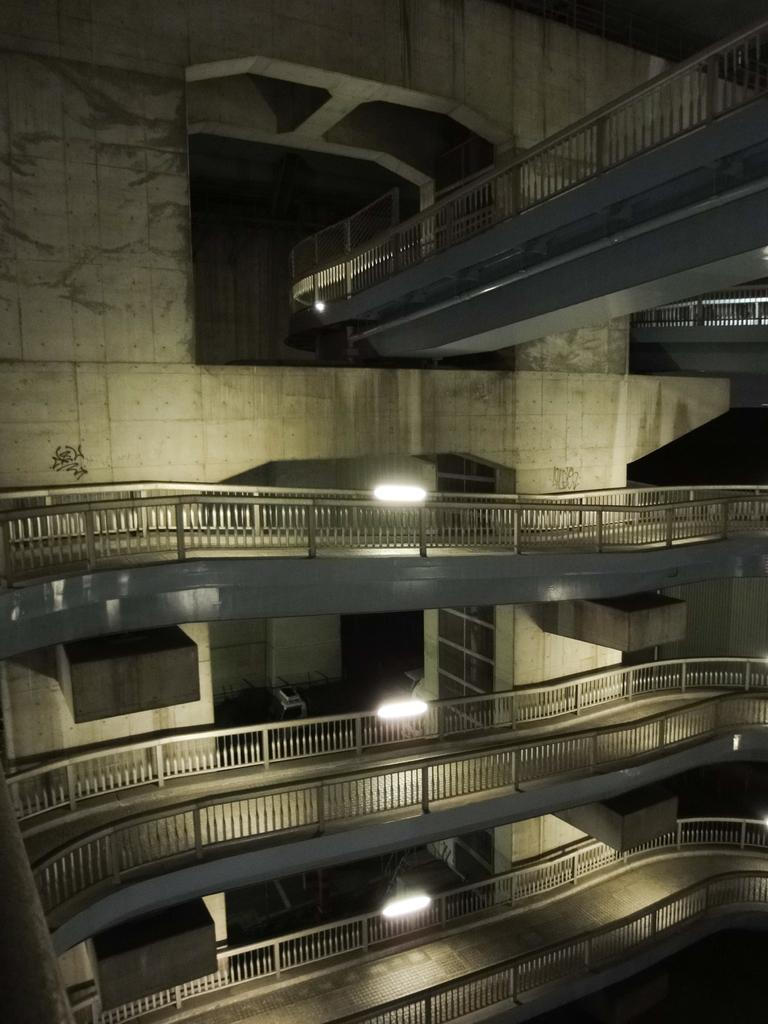What type of structure is depicted in the image? The image shows floors with railings around them. What can be seen in the background of the image? There is a wall in the background of the image. What might be the purpose of the railings around the floors? The railings around the floors could provide safety or support for people using the floors. How does the loss of appetite affect the floors in the image? There is no mention of loss of appetite in the image, and it does not have any impact on the floors. What type of bells can be heard ringing in the image? There are no bells present in the image, so it is not possible to hear them ringing. 